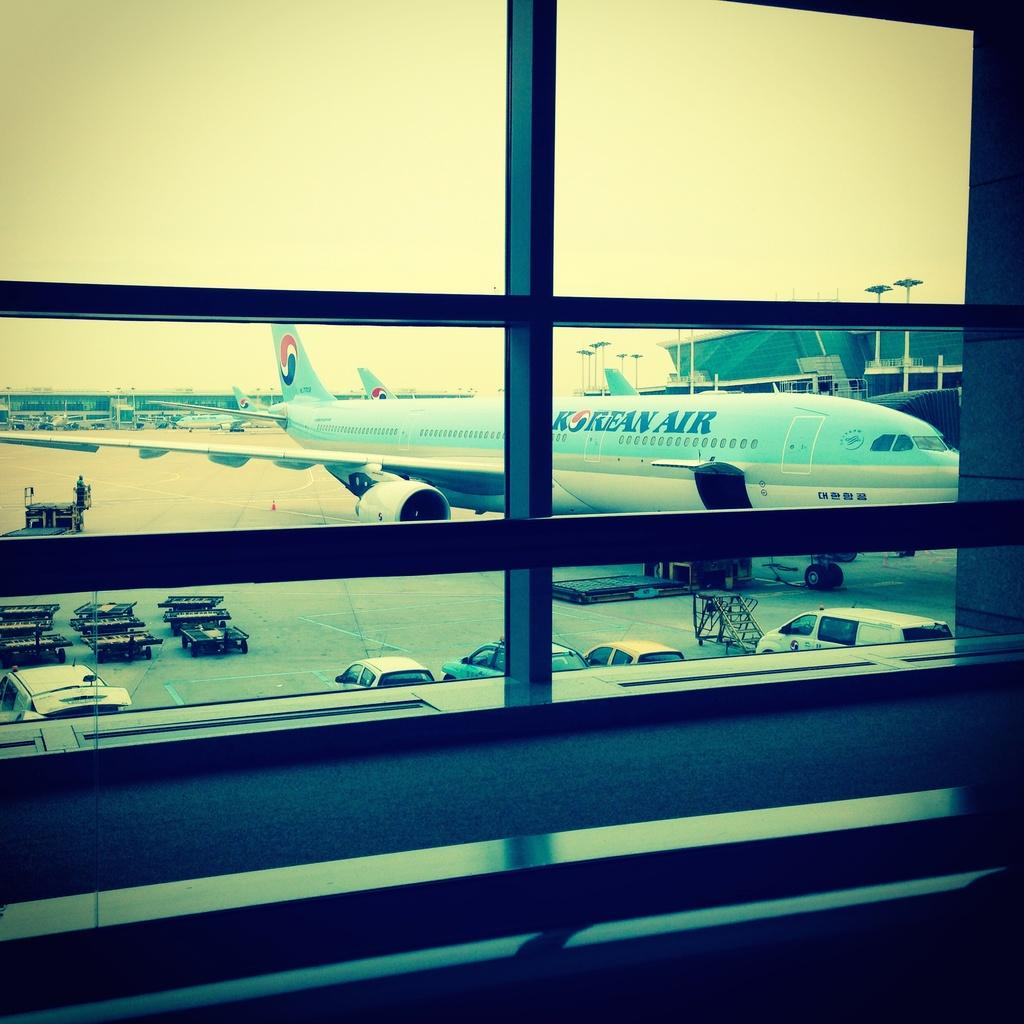<image>
Present a compact description of the photo's key features. an airport window looking out at a Korean Air at a gate 